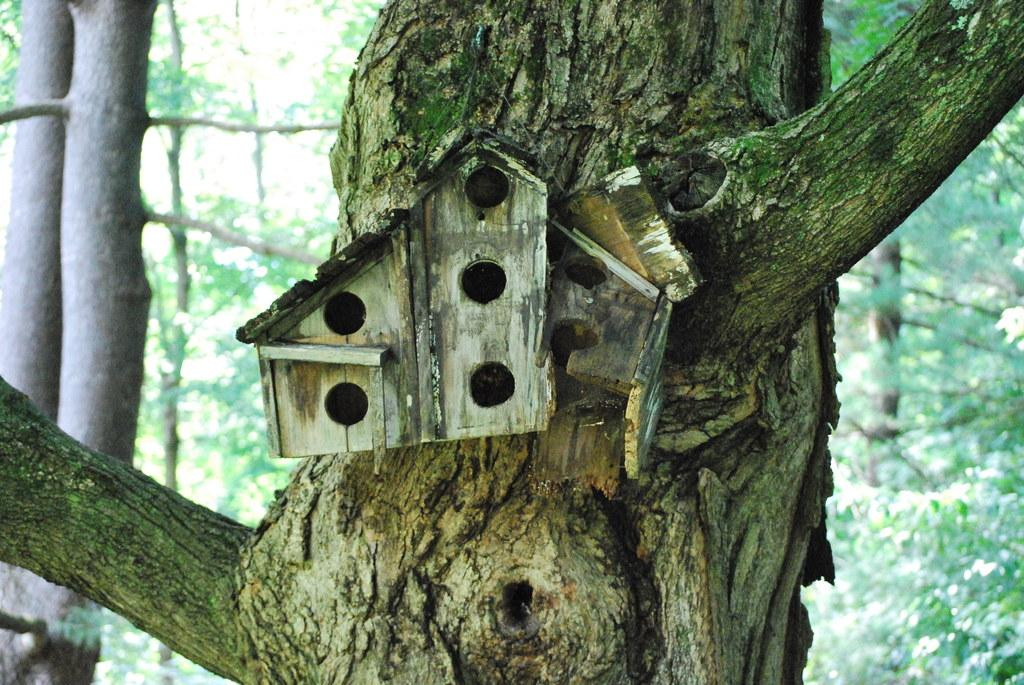What structure is featured in the image? There is a bird house in the image. Where is the bird house located? The bird house is on a tree trunk. What else can be seen in the image besides the bird house? There are trees visible in the image. How many legs does the bird house have in the image? A bird house does not have legs; it is a stationary structure. What type of grip does the bird house have on the tree trunk? The bird house is not shown to have a grip on the tree trunk; it is simply resting on it. 